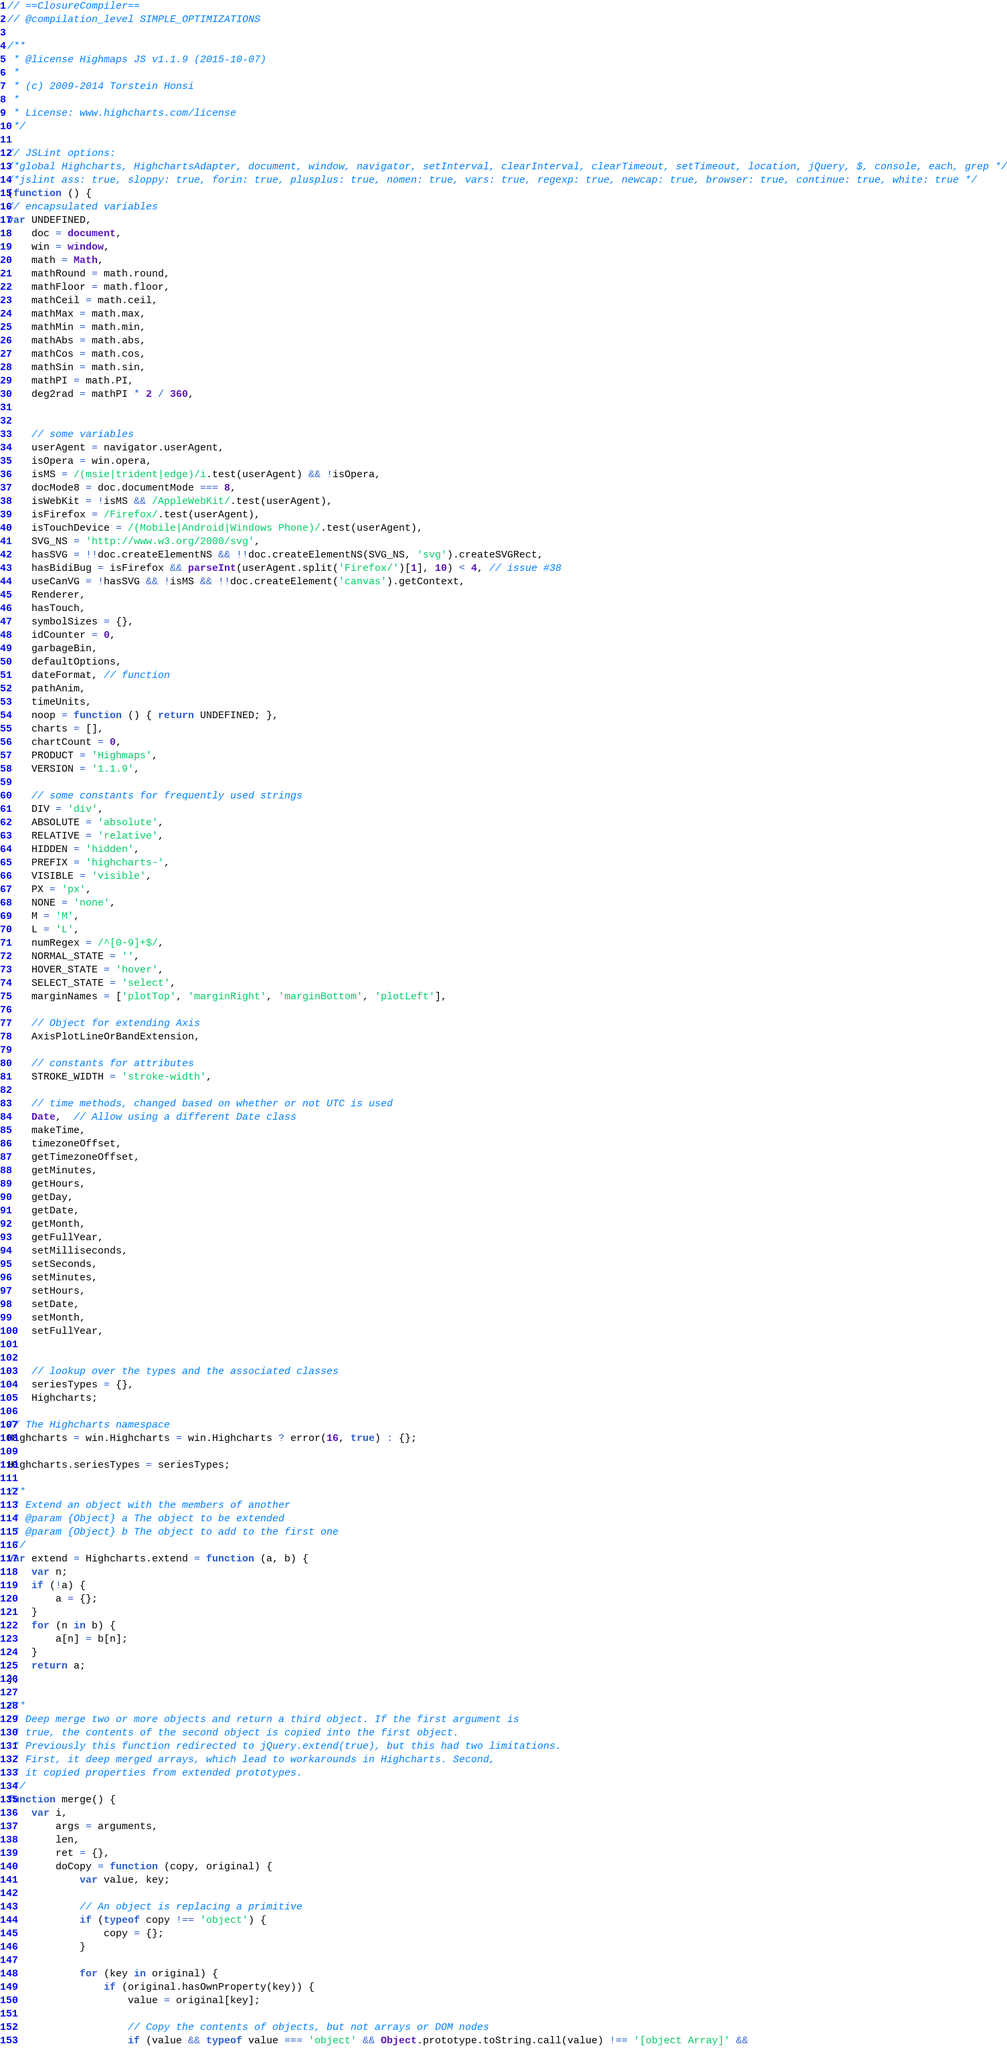<code> <loc_0><loc_0><loc_500><loc_500><_JavaScript_>// ==ClosureCompiler==
// @compilation_level SIMPLE_OPTIMIZATIONS

/**
 * @license Highmaps JS v1.1.9 (2015-10-07)
 *
 * (c) 2009-2014 Torstein Honsi
 *
 * License: www.highcharts.com/license
 */

// JSLint options:
/*global Highcharts, HighchartsAdapter, document, window, navigator, setInterval, clearInterval, clearTimeout, setTimeout, location, jQuery, $, console, each, grep */
/*jslint ass: true, sloppy: true, forin: true, plusplus: true, nomen: true, vars: true, regexp: true, newcap: true, browser: true, continue: true, white: true */
(function () {
// encapsulated variables
var UNDEFINED,
	doc = document,
	win = window,
	math = Math,
	mathRound = math.round,
	mathFloor = math.floor,
	mathCeil = math.ceil,
	mathMax = math.max,
	mathMin = math.min,
	mathAbs = math.abs,
	mathCos = math.cos,
	mathSin = math.sin,
	mathPI = math.PI,
	deg2rad = mathPI * 2 / 360,


	// some variables
	userAgent = navigator.userAgent,
	isOpera = win.opera,
	isMS = /(msie|trident|edge)/i.test(userAgent) && !isOpera,
	docMode8 = doc.documentMode === 8,
	isWebKit = !isMS && /AppleWebKit/.test(userAgent),
	isFirefox = /Firefox/.test(userAgent),
	isTouchDevice = /(Mobile|Android|Windows Phone)/.test(userAgent),
	SVG_NS = 'http://www.w3.org/2000/svg',
	hasSVG = !!doc.createElementNS && !!doc.createElementNS(SVG_NS, 'svg').createSVGRect,
	hasBidiBug = isFirefox && parseInt(userAgent.split('Firefox/')[1], 10) < 4, // issue #38
	useCanVG = !hasSVG && !isMS && !!doc.createElement('canvas').getContext,
	Renderer,
	hasTouch,
	symbolSizes = {},
	idCounter = 0,
	garbageBin,
	defaultOptions,
	dateFormat, // function
	pathAnim,
	timeUnits,
	noop = function () { return UNDEFINED; },
	charts = [],
	chartCount = 0,
	PRODUCT = 'Highmaps',
	VERSION = '1.1.9',

	// some constants for frequently used strings
	DIV = 'div',
	ABSOLUTE = 'absolute',
	RELATIVE = 'relative',
	HIDDEN = 'hidden',
	PREFIX = 'highcharts-',
	VISIBLE = 'visible',
	PX = 'px',
	NONE = 'none',
	M = 'M',
	L = 'L',
	numRegex = /^[0-9]+$/,
	NORMAL_STATE = '',
	HOVER_STATE = 'hover',
	SELECT_STATE = 'select',
	marginNames = ['plotTop', 'marginRight', 'marginBottom', 'plotLeft'],
	
	// Object for extending Axis
	AxisPlotLineOrBandExtension,

	// constants for attributes
	STROKE_WIDTH = 'stroke-width',

	// time methods, changed based on whether or not UTC is used
	Date,  // Allow using a different Date class
	makeTime,
	timezoneOffset,
	getTimezoneOffset,
	getMinutes,
	getHours,
	getDay,
	getDate,
	getMonth,
	getFullYear,
	setMilliseconds,
	setSeconds,
	setMinutes,
	setHours,
	setDate,
	setMonth,
	setFullYear,


	// lookup over the types and the associated classes
	seriesTypes = {},
	Highcharts;

// The Highcharts namespace
Highcharts = win.Highcharts = win.Highcharts ? error(16, true) : {};

Highcharts.seriesTypes = seriesTypes;

/**
 * Extend an object with the members of another
 * @param {Object} a The object to be extended
 * @param {Object} b The object to add to the first one
 */
var extend = Highcharts.extend = function (a, b) {
	var n;
	if (!a) {
		a = {};
	}
	for (n in b) {
		a[n] = b[n];
	}
	return a;
};
	
/**
 * Deep merge two or more objects and return a third object. If the first argument is
 * true, the contents of the second object is copied into the first object.
 * Previously this function redirected to jQuery.extend(true), but this had two limitations.
 * First, it deep merged arrays, which lead to workarounds in Highcharts. Second,
 * it copied properties from extended prototypes. 
 */
function merge() {
	var i,
		args = arguments,
		len,
		ret = {},
		doCopy = function (copy, original) {
			var value, key;

			// An object is replacing a primitive
			if (typeof copy !== 'object') {
				copy = {};
			}

			for (key in original) {
				if (original.hasOwnProperty(key)) {
					value = original[key];

					// Copy the contents of objects, but not arrays or DOM nodes
					if (value && typeof value === 'object' && Object.prototype.toString.call(value) !== '[object Array]' &&</code> 